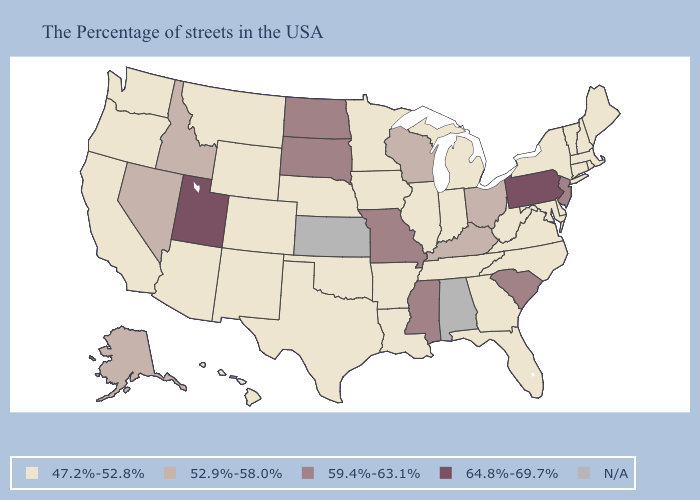Name the states that have a value in the range 47.2%-52.8%?
Short answer required. Maine, Massachusetts, Rhode Island, New Hampshire, Vermont, Connecticut, New York, Delaware, Maryland, Virginia, North Carolina, West Virginia, Florida, Georgia, Michigan, Indiana, Tennessee, Illinois, Louisiana, Arkansas, Minnesota, Iowa, Nebraska, Oklahoma, Texas, Wyoming, Colorado, New Mexico, Montana, Arizona, California, Washington, Oregon, Hawaii. Does Kentucky have the lowest value in the South?
Answer briefly. No. What is the value of North Carolina?
Be succinct. 47.2%-52.8%. Does the first symbol in the legend represent the smallest category?
Write a very short answer. Yes. What is the value of Idaho?
Give a very brief answer. 52.9%-58.0%. What is the value of Louisiana?
Concise answer only. 47.2%-52.8%. Among the states that border New York , which have the lowest value?
Concise answer only. Massachusetts, Vermont, Connecticut. Among the states that border Michigan , which have the lowest value?
Write a very short answer. Indiana. What is the lowest value in the USA?
Give a very brief answer. 47.2%-52.8%. What is the value of Arizona?
Quick response, please. 47.2%-52.8%. Among the states that border Montana , which have the highest value?
Short answer required. South Dakota, North Dakota. How many symbols are there in the legend?
Be succinct. 5. Name the states that have a value in the range 47.2%-52.8%?
Give a very brief answer. Maine, Massachusetts, Rhode Island, New Hampshire, Vermont, Connecticut, New York, Delaware, Maryland, Virginia, North Carolina, West Virginia, Florida, Georgia, Michigan, Indiana, Tennessee, Illinois, Louisiana, Arkansas, Minnesota, Iowa, Nebraska, Oklahoma, Texas, Wyoming, Colorado, New Mexico, Montana, Arizona, California, Washington, Oregon, Hawaii. Does the first symbol in the legend represent the smallest category?
Be succinct. Yes. 